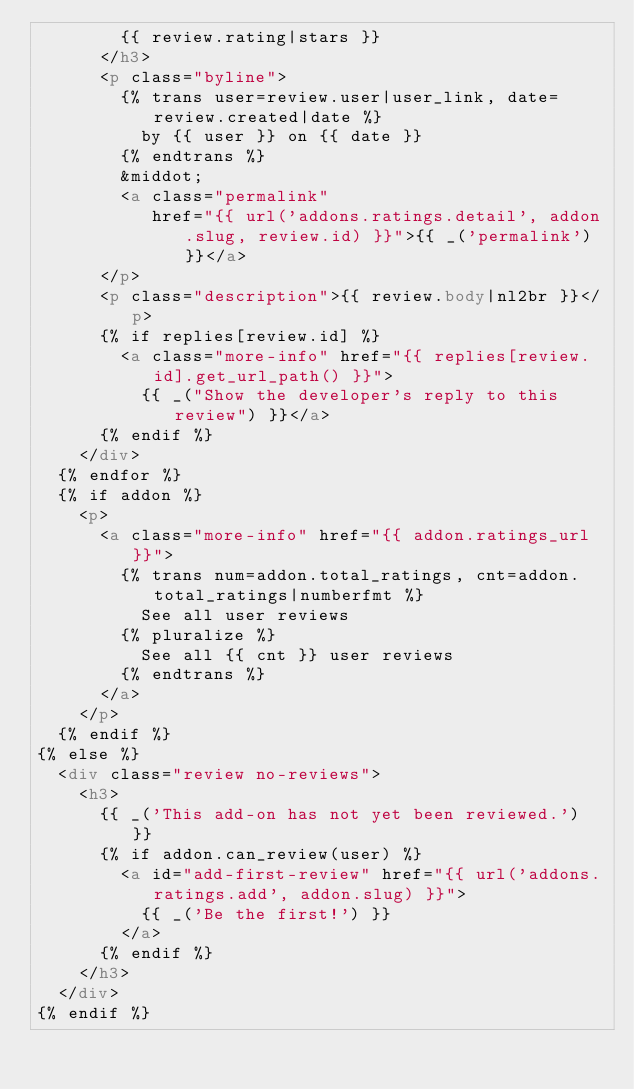Convert code to text. <code><loc_0><loc_0><loc_500><loc_500><_HTML_>        {{ review.rating|stars }}
      </h3>
      <p class="byline">
        {% trans user=review.user|user_link, date=review.created|date %}
          by {{ user }} on {{ date }}
        {% endtrans %}
        &middot;
        <a class="permalink"
           href="{{ url('addons.ratings.detail', addon.slug, review.id) }}">{{ _('permalink') }}</a>
      </p>
      <p class="description">{{ review.body|nl2br }}</p>
      {% if replies[review.id] %}
        <a class="more-info" href="{{ replies[review.id].get_url_path() }}">
          {{ _("Show the developer's reply to this review") }}</a>
      {% endif %}
    </div>
  {% endfor %}
  {% if addon %}
    <p>
      <a class="more-info" href="{{ addon.ratings_url }}">
        {% trans num=addon.total_ratings, cnt=addon.total_ratings|numberfmt %}
          See all user reviews
        {% pluralize %}
          See all {{ cnt }} user reviews
        {% endtrans %}
      </a>
    </p>
  {% endif %}
{% else %}
  <div class="review no-reviews">
    <h3>
      {{ _('This add-on has not yet been reviewed.') }}
      {% if addon.can_review(user) %}
        <a id="add-first-review" href="{{ url('addons.ratings.add', addon.slug) }}">
          {{ _('Be the first!') }}
        </a>
      {% endif %}
    </h3>
  </div>
{% endif %}
</code> 